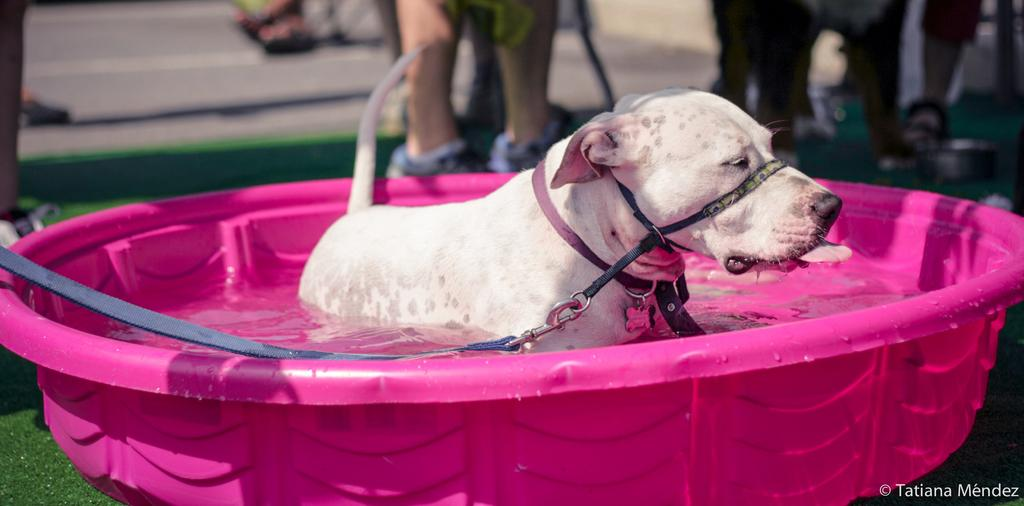What object is present in the image that can hold water? There is a tub in the image that can hold water. What is inside the tub? There is water in the tub. What animal is in the water? There is a dog in the water. Can you see any people in the image? Yes, there are legs of persons visible in the background. Is there any text in the image? Yes, there is text in the bottom right corner of the image. What type of apparel is being sold at the market in the image? There is no market or apparel present in the image; it features a tub with water and a dog. Can you hear the bell ringing in the image? There is no bell present in the image, so it cannot be heard. 